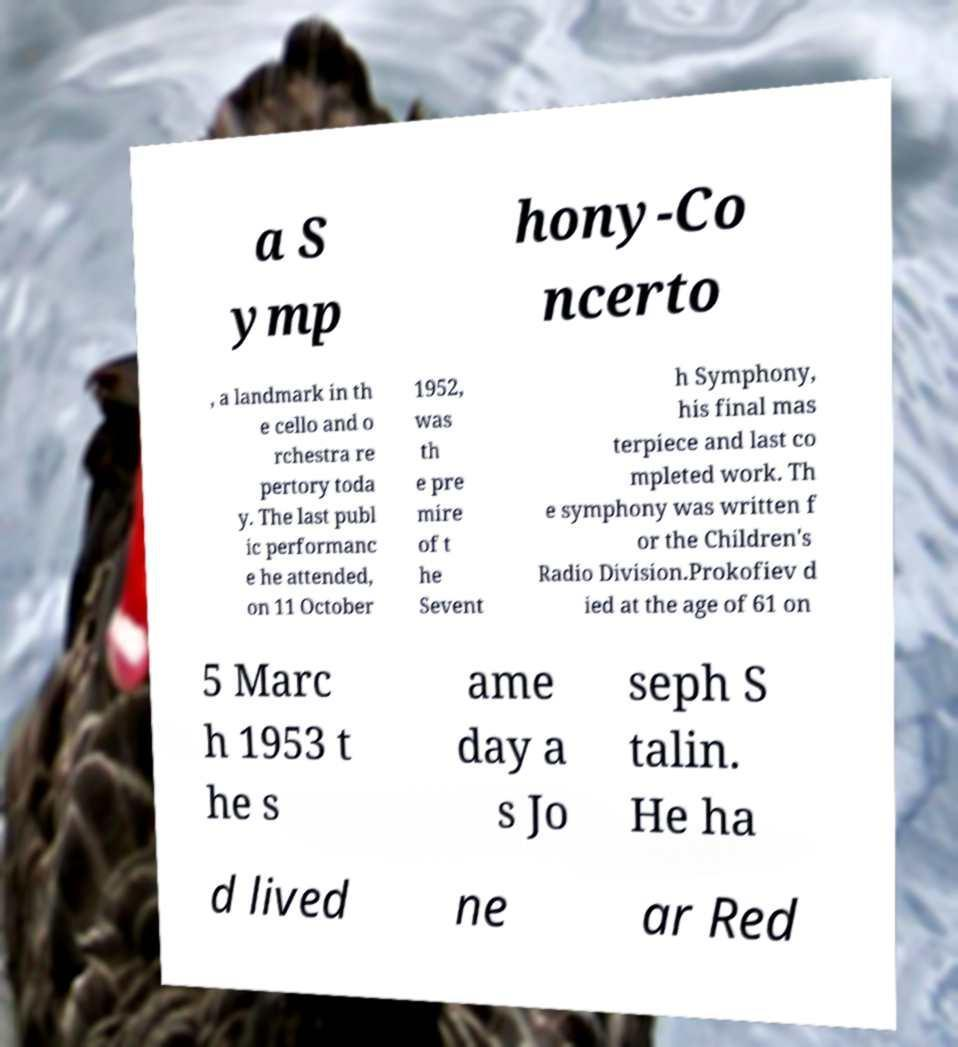Please identify and transcribe the text found in this image. a S ymp hony-Co ncerto , a landmark in th e cello and o rchestra re pertory toda y. The last publ ic performanc e he attended, on 11 October 1952, was th e pre mire of t he Sevent h Symphony, his final mas terpiece and last co mpleted work. Th e symphony was written f or the Children's Radio Division.Prokofiev d ied at the age of 61 on 5 Marc h 1953 t he s ame day a s Jo seph S talin. He ha d lived ne ar Red 